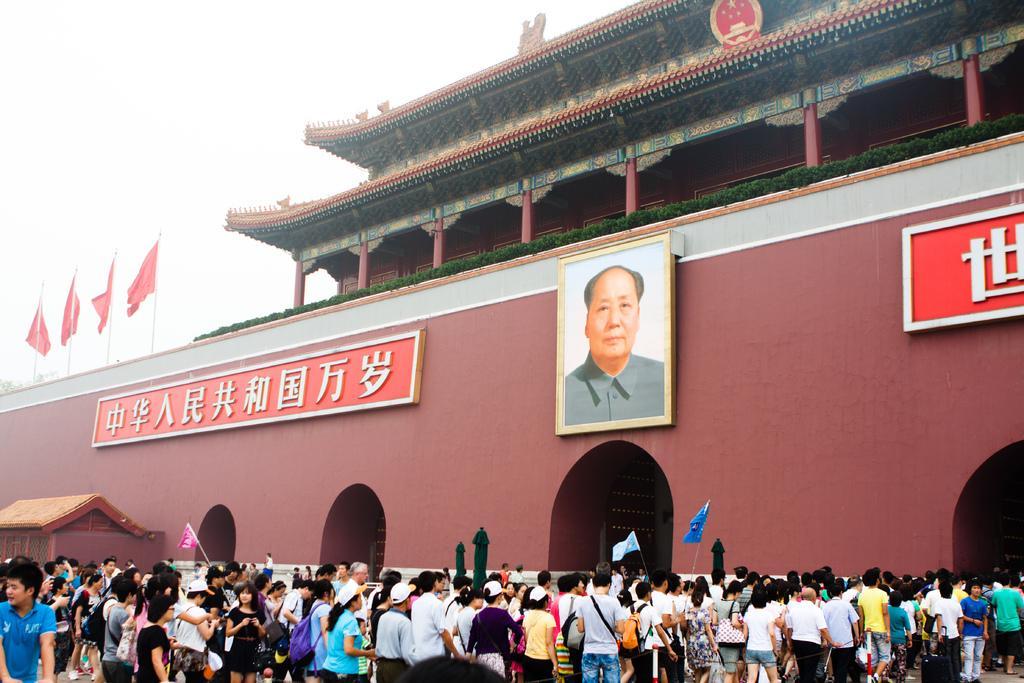Describe this image in one or two sentences. To this building there is a picture, plants and boards. Here we can see flags. In-front of this building there are people. Few people are holding flags. This is shed. Background there is a sky. 